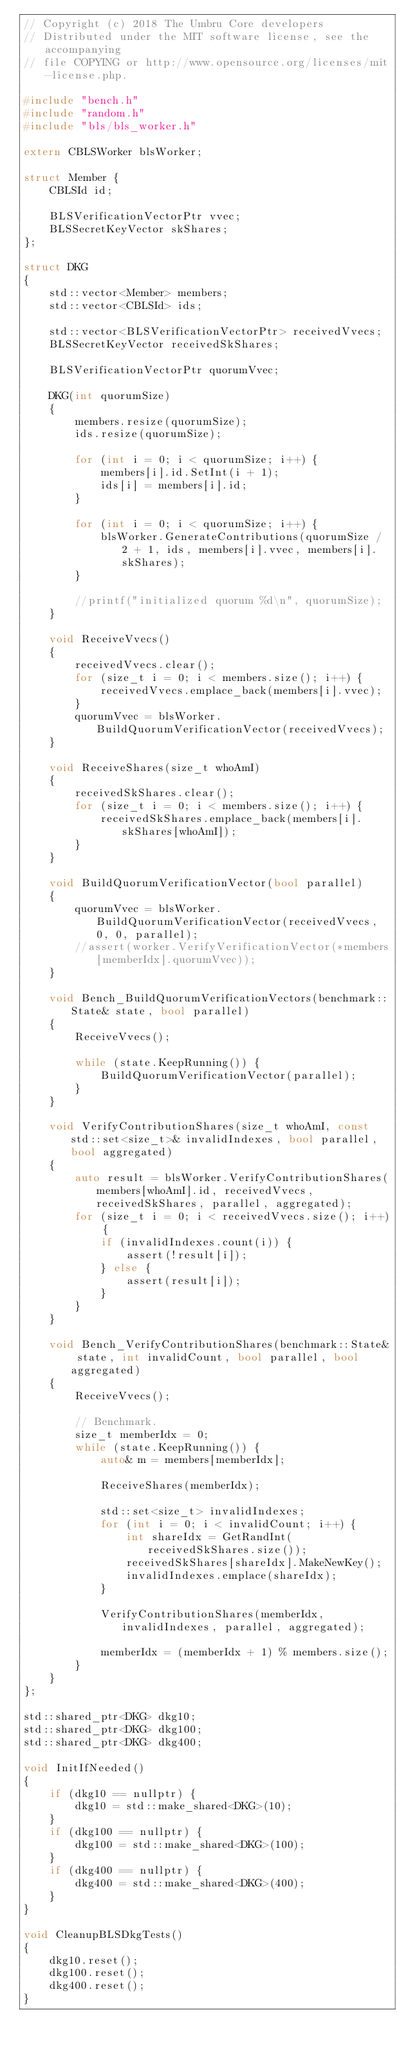Convert code to text. <code><loc_0><loc_0><loc_500><loc_500><_C++_>// Copyright (c) 2018 The Umbru Core developers
// Distributed under the MIT software license, see the accompanying
// file COPYING or http://www.opensource.org/licenses/mit-license.php.

#include "bench.h"
#include "random.h"
#include "bls/bls_worker.h"

extern CBLSWorker blsWorker;

struct Member {
    CBLSId id;

    BLSVerificationVectorPtr vvec;
    BLSSecretKeyVector skShares;
};

struct DKG
{
    std::vector<Member> members;
    std::vector<CBLSId> ids;

    std::vector<BLSVerificationVectorPtr> receivedVvecs;
    BLSSecretKeyVector receivedSkShares;

    BLSVerificationVectorPtr quorumVvec;

    DKG(int quorumSize)
    {
        members.resize(quorumSize);
        ids.resize(quorumSize);

        for (int i = 0; i < quorumSize; i++) {
            members[i].id.SetInt(i + 1);
            ids[i] = members[i].id;
        }

        for (int i = 0; i < quorumSize; i++) {
            blsWorker.GenerateContributions(quorumSize / 2 + 1, ids, members[i].vvec, members[i].skShares);
        }

        //printf("initialized quorum %d\n", quorumSize);
    }

    void ReceiveVvecs()
    {
        receivedVvecs.clear();
        for (size_t i = 0; i < members.size(); i++) {
            receivedVvecs.emplace_back(members[i].vvec);
        }
        quorumVvec = blsWorker.BuildQuorumVerificationVector(receivedVvecs);
    }

    void ReceiveShares(size_t whoAmI)
    {
        receivedSkShares.clear();
        for (size_t i = 0; i < members.size(); i++) {
            receivedSkShares.emplace_back(members[i].skShares[whoAmI]);
        }
    }

    void BuildQuorumVerificationVector(bool parallel)
    {
        quorumVvec = blsWorker.BuildQuorumVerificationVector(receivedVvecs, 0, 0, parallel);
        //assert(worker.VerifyVerificationVector(*members[memberIdx].quorumVvec));
    }

    void Bench_BuildQuorumVerificationVectors(benchmark::State& state, bool parallel)
    {
        ReceiveVvecs();

        while (state.KeepRunning()) {
            BuildQuorumVerificationVector(parallel);
        }
    }

    void VerifyContributionShares(size_t whoAmI, const std::set<size_t>& invalidIndexes, bool parallel, bool aggregated)
    {
        auto result = blsWorker.VerifyContributionShares(members[whoAmI].id, receivedVvecs, receivedSkShares, parallel, aggregated);
        for (size_t i = 0; i < receivedVvecs.size(); i++) {
            if (invalidIndexes.count(i)) {
                assert(!result[i]);
            } else {
                assert(result[i]);
            }
        }
    }

    void Bench_VerifyContributionShares(benchmark::State& state, int invalidCount, bool parallel, bool aggregated)
    {
        ReceiveVvecs();

        // Benchmark.
        size_t memberIdx = 0;
        while (state.KeepRunning()) {
            auto& m = members[memberIdx];

            ReceiveShares(memberIdx);

            std::set<size_t> invalidIndexes;
            for (int i = 0; i < invalidCount; i++) {
                int shareIdx = GetRandInt(receivedSkShares.size());
                receivedSkShares[shareIdx].MakeNewKey();
                invalidIndexes.emplace(shareIdx);
            }

            VerifyContributionShares(memberIdx, invalidIndexes, parallel, aggregated);

            memberIdx = (memberIdx + 1) % members.size();
        }
    }
};

std::shared_ptr<DKG> dkg10;
std::shared_ptr<DKG> dkg100;
std::shared_ptr<DKG> dkg400;

void InitIfNeeded()
{
    if (dkg10 == nullptr) {
        dkg10 = std::make_shared<DKG>(10);
    }
    if (dkg100 == nullptr) {
        dkg100 = std::make_shared<DKG>(100);
    }
    if (dkg400 == nullptr) {
        dkg400 = std::make_shared<DKG>(400);
    }
}

void CleanupBLSDkgTests()
{
    dkg10.reset();
    dkg100.reset();
    dkg400.reset();
}


</code> 